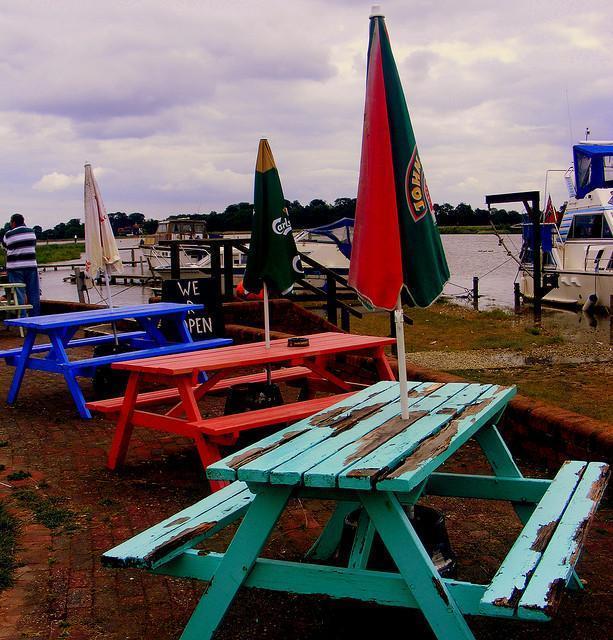How many benches can you see?
Give a very brief answer. 2. How many umbrellas can be seen?
Give a very brief answer. 3. 